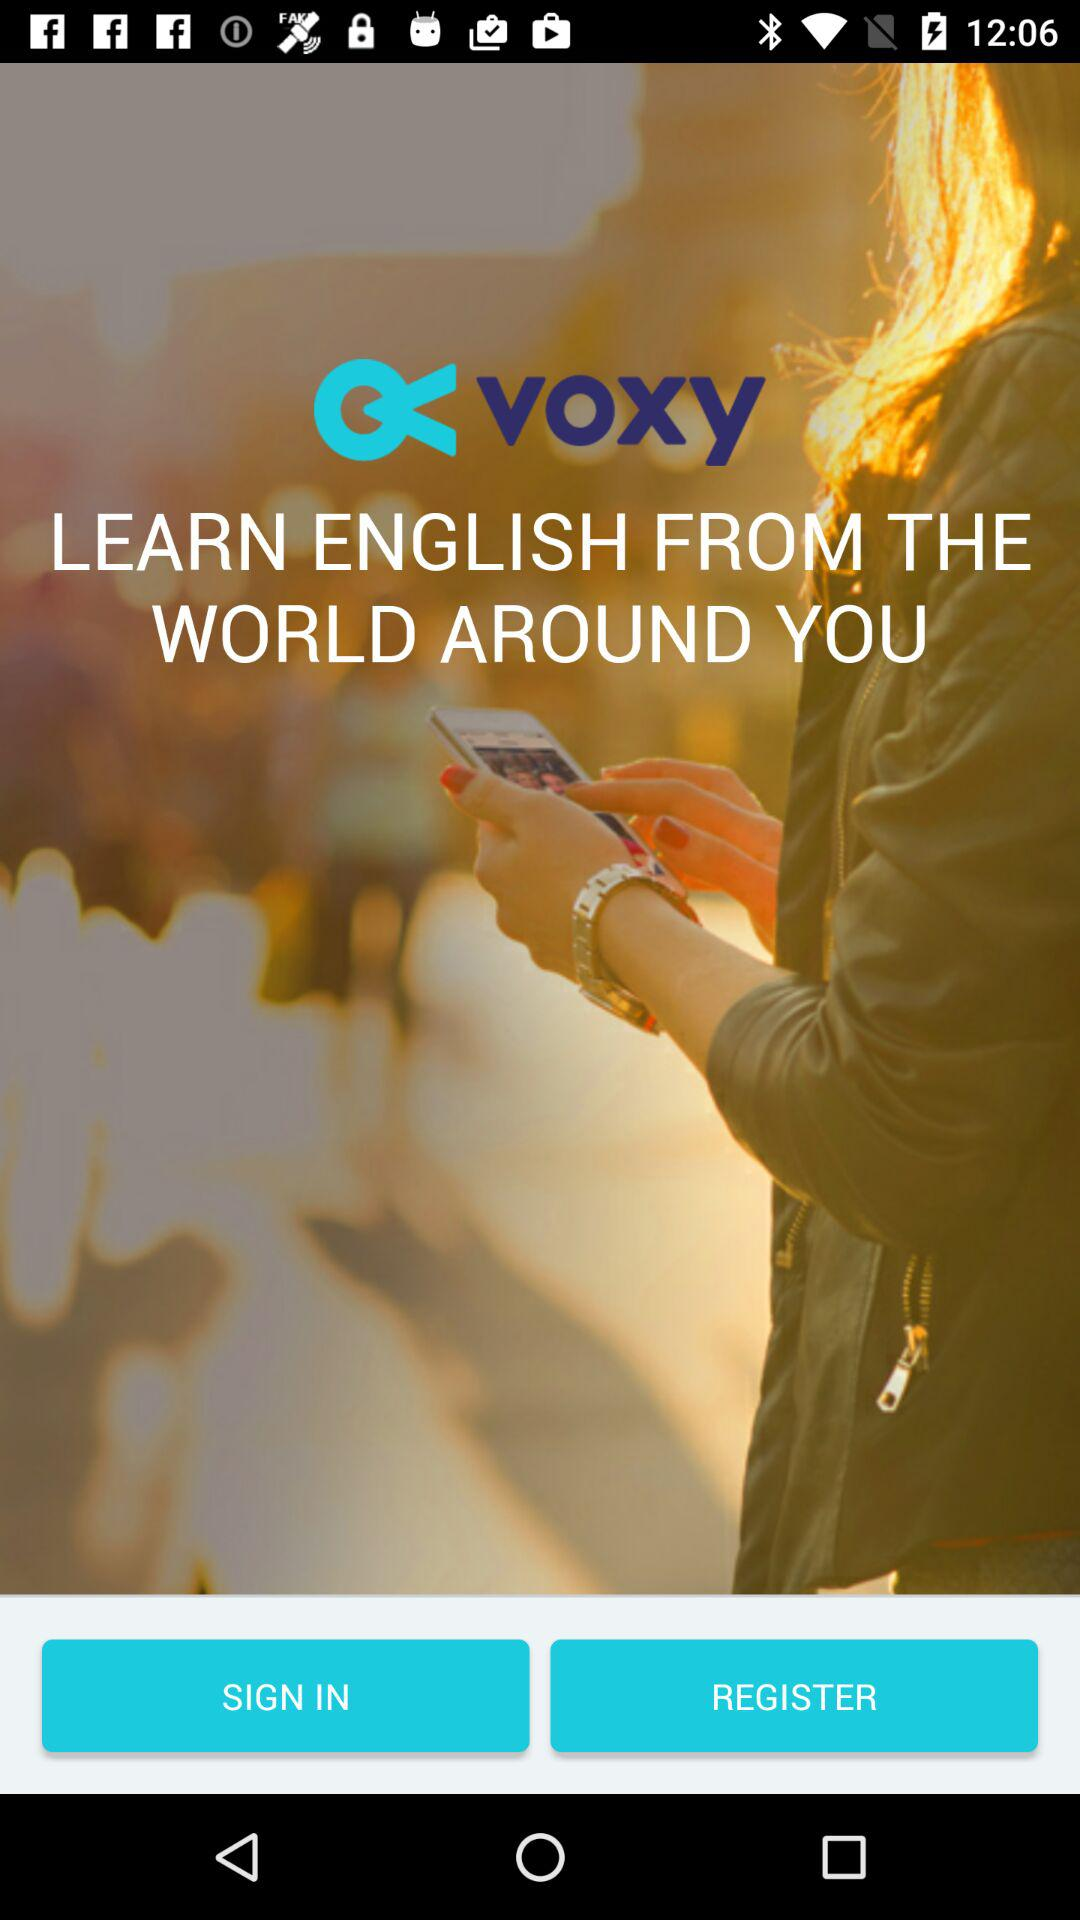Is the user registered?
When the provided information is insufficient, respond with <no answer>. <no answer> 